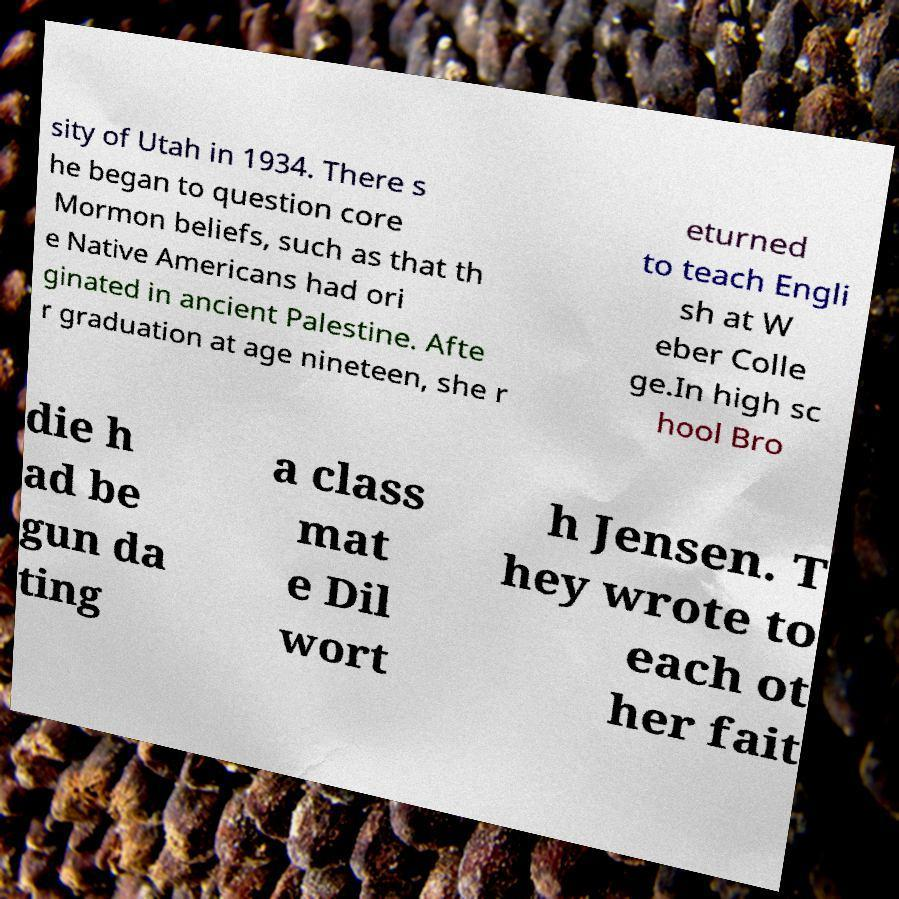For documentation purposes, I need the text within this image transcribed. Could you provide that? sity of Utah in 1934. There s he began to question core Mormon beliefs, such as that th e Native Americans had ori ginated in ancient Palestine. Afte r graduation at age nineteen, she r eturned to teach Engli sh at W eber Colle ge.In high sc hool Bro die h ad be gun da ting a class mat e Dil wort h Jensen. T hey wrote to each ot her fait 